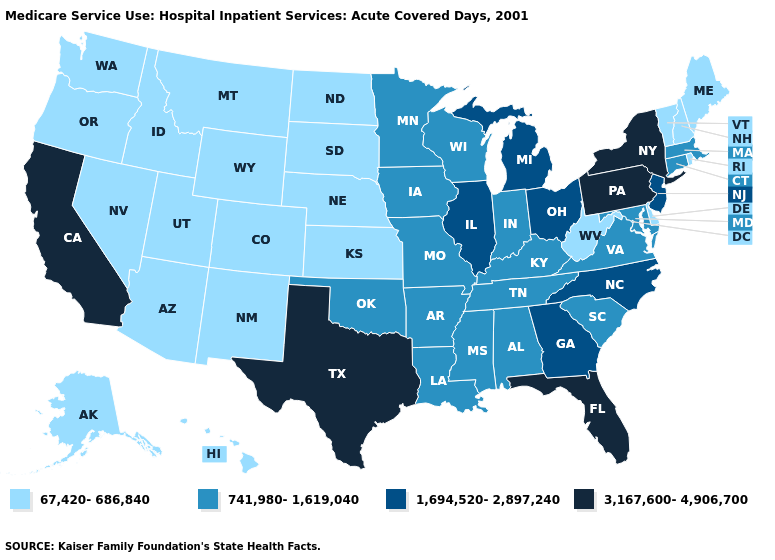What is the value of Arkansas?
Give a very brief answer. 741,980-1,619,040. Among the states that border Georgia , which have the highest value?
Quick response, please. Florida. Among the states that border Missouri , which have the lowest value?
Concise answer only. Kansas, Nebraska. What is the lowest value in the Northeast?
Write a very short answer. 67,420-686,840. What is the value of New Hampshire?
Quick response, please. 67,420-686,840. Name the states that have a value in the range 67,420-686,840?
Concise answer only. Alaska, Arizona, Colorado, Delaware, Hawaii, Idaho, Kansas, Maine, Montana, Nebraska, Nevada, New Hampshire, New Mexico, North Dakota, Oregon, Rhode Island, South Dakota, Utah, Vermont, Washington, West Virginia, Wyoming. Name the states that have a value in the range 3,167,600-4,906,700?
Keep it brief. California, Florida, New York, Pennsylvania, Texas. What is the highest value in the USA?
Answer briefly. 3,167,600-4,906,700. Which states have the lowest value in the USA?
Be succinct. Alaska, Arizona, Colorado, Delaware, Hawaii, Idaho, Kansas, Maine, Montana, Nebraska, Nevada, New Hampshire, New Mexico, North Dakota, Oregon, Rhode Island, South Dakota, Utah, Vermont, Washington, West Virginia, Wyoming. Does Virginia have the lowest value in the South?
Answer briefly. No. What is the value of Louisiana?
Give a very brief answer. 741,980-1,619,040. Name the states that have a value in the range 3,167,600-4,906,700?
Quick response, please. California, Florida, New York, Pennsylvania, Texas. Does Oregon have the lowest value in the USA?
Keep it brief. Yes. Does New York have the highest value in the USA?
Short answer required. Yes. Name the states that have a value in the range 3,167,600-4,906,700?
Write a very short answer. California, Florida, New York, Pennsylvania, Texas. 